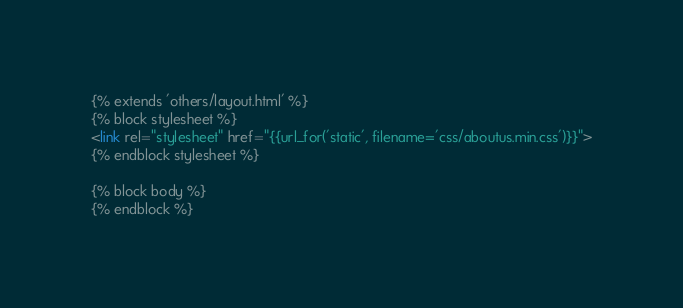<code> <loc_0><loc_0><loc_500><loc_500><_HTML_>{% extends 'others/layout.html' %}
{% block stylesheet %}
<link rel="stylesheet" href="{{url_for('static', filename='css/aboutus.min.css')}}">
{% endblock stylesheet %}

{% block body %}
{% endblock %}</code> 